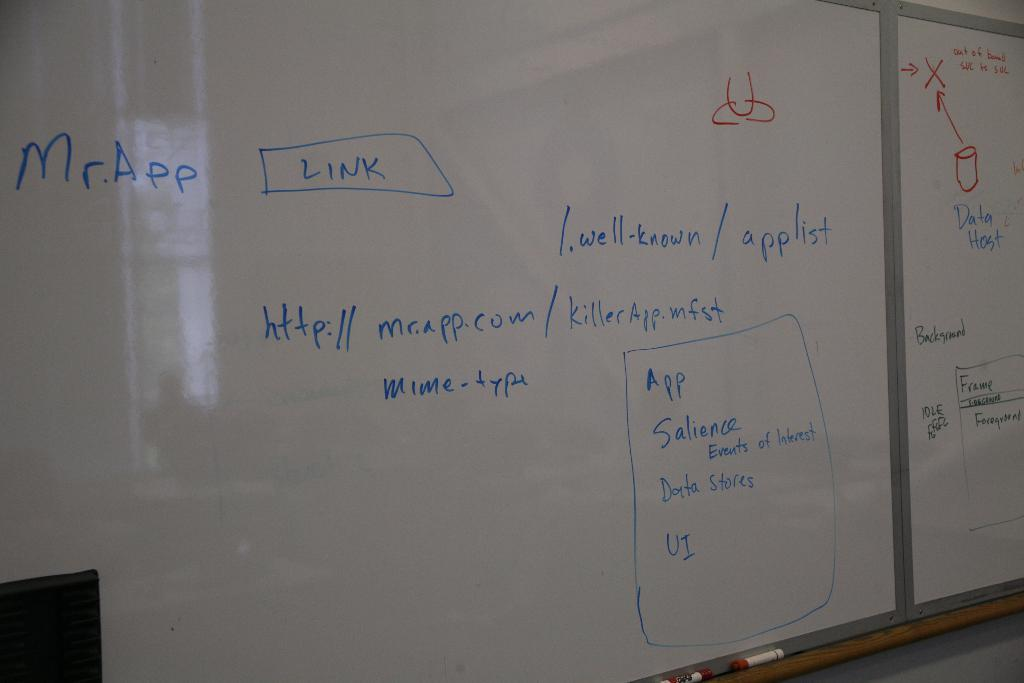<image>
Relay a brief, clear account of the picture shown. A whiteboard has notes about Mr. App, including a box that says LINK. 